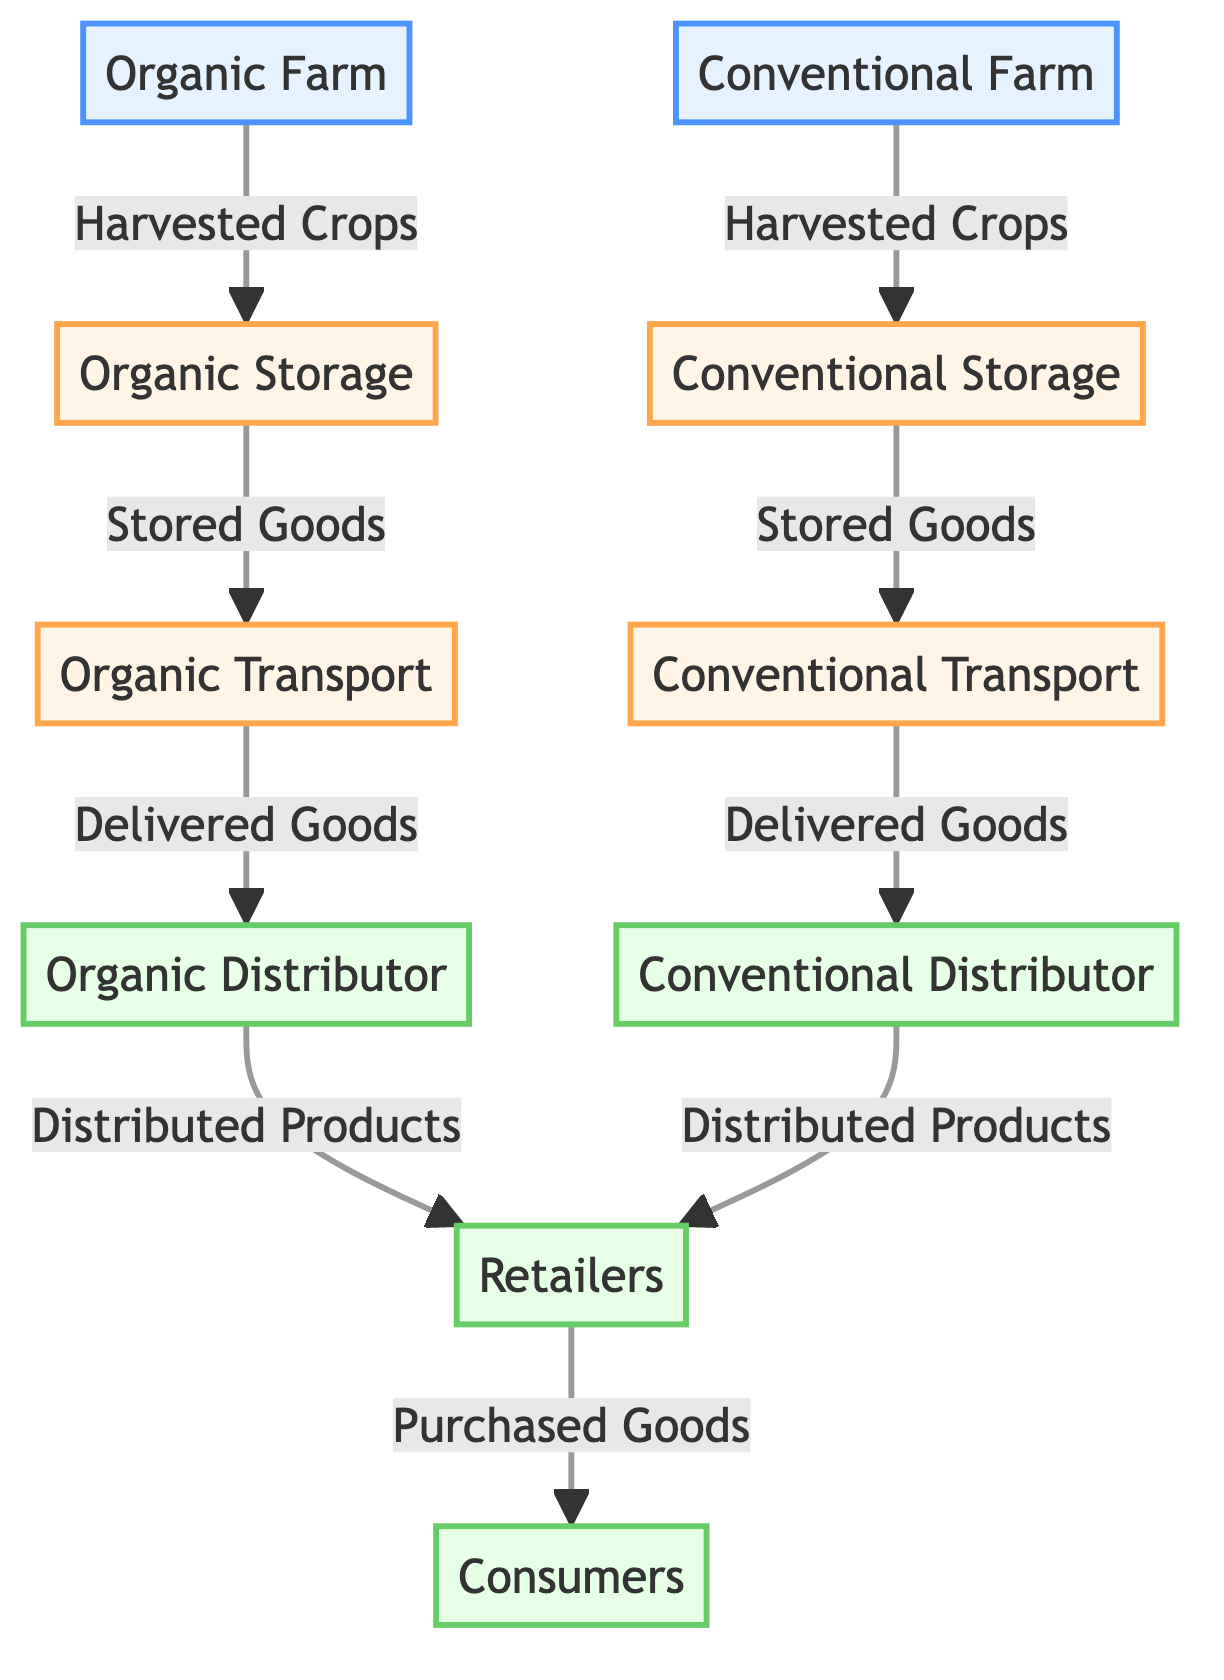What are the two types of farms represented in the diagram? The diagram illustrates two types of farms: Organic Farm and Conventional Farm, which are the initial nodes in the flowchart.
Answer: Organic Farm, Conventional Farm How many storage nodes are there? The diagram contains two storage nodes: Organic Storage and Conventional Storage. Thus, there are a total of two storage nodes present.
Answer: 2 What do stored goods from the organic farm get transported to? The stored goods from the Organic Storage are transported to the Organic Transport node as indicated by the arrow from Organic Storage to Organic Transport.
Answer: Organic Transport Which type of distributor is associated with the organic supply chain? The diagram shows that Organic Distributor is linked directly to organic transport, hence it is the type of distributor associated with the organic supply chain.
Answer: Organic Distributor Which node represents the final point in the supply chain for both farming practices? The Consumers node serves as the final point in the supply chain, as it is the last node connected to both retail distributions.
Answer: Consumers Which farm has a corresponding storage, transport, and distributor in the diagram? Both the Organic Farm and Conventional Farm have corresponding nodes for storage, transport, and distributor, making them parallel in their operations depicted in the diagram.
Answer: Both What is the relationship between retailers and consumers in this diagram? In the diagram, retailers distribute purchased goods to consumers, indicating a direct relationship where retailers act as intermediaries to consumers.
Answer: Retailers distribute to consumers If organic crops are harvested, where do they go next? After harvesting, organic crops go to Organic Storage where they are held before further processing or distribution.
Answer: Organic Storage How do conventional crops end up with consumers? Conventional crops are harvested, stored in Conventional Storage, then transported via Conventional Transport, distributed by Conventional Distributor, and finally sold to retailers who provide them to consumers.
Answer: Through storage, transport, distributor, then retailers to consumers 